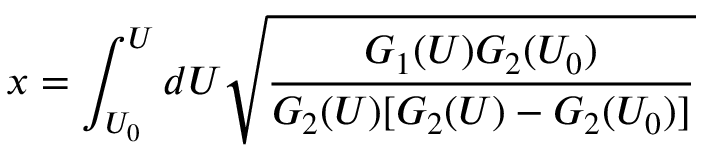<formula> <loc_0><loc_0><loc_500><loc_500>x = \int _ { U _ { 0 } } ^ { U } d U \sqrt { \frac { G _ { 1 } ( U ) G _ { 2 } ( U _ { 0 } ) } { G _ { 2 } ( U ) [ G _ { 2 } ( U ) - G _ { 2 } ( U _ { 0 } ) ] } }</formula> 